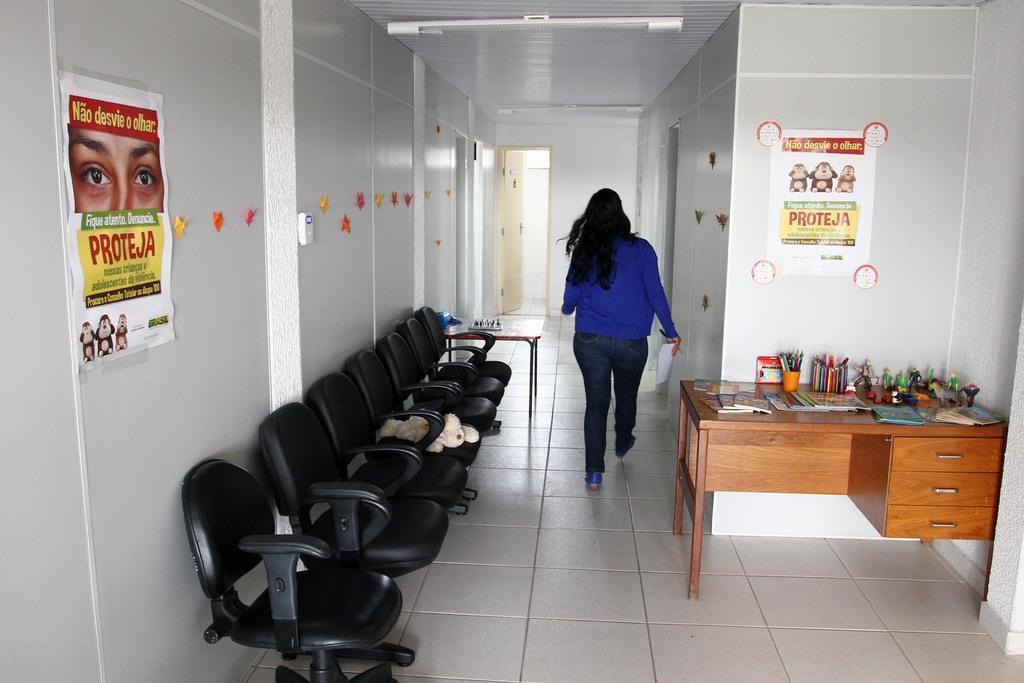Please provide a concise description of this image. In this picture this person walking on the floor. We can see chairs. We can see wall. On the wall we can posters. This is door. There is a table. On the table we can see books,Pencils,Toys. On the top we can see light. 